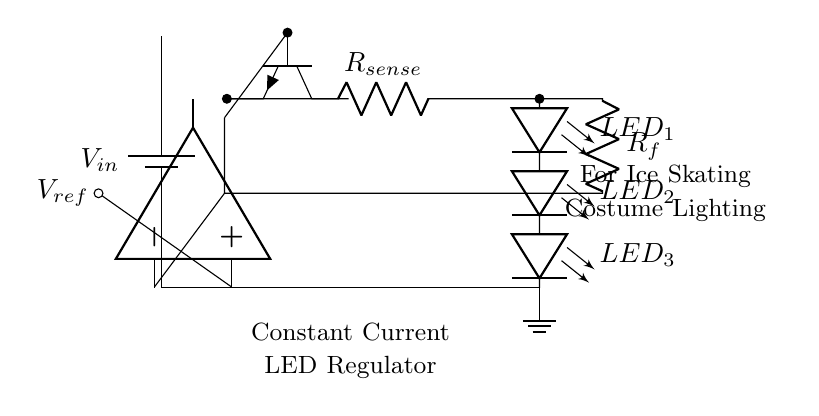What is the type of voltage source in this circuit? The circuit uses a battery, which is shown as the component labeled "Vin." This indicates that it is a direct current source providing a constant voltage.
Answer: battery What is the function of R_sense in the circuit? R_sense is used for current sensing. It measures the current flowing through the LED string, allowing the regulation circuit to adjust the current accordingly to achieve a constant current through the LEDs.
Answer: current sensing How many LEDs are connected in series in this circuit? There are three LEDs identified in the circuit diagram labeled as "LED_1," "LED_2," and "LED_3." Each is connected in series, which means they share the same current and the total voltage across them is the sum of individual voltages.
Answer: three What component controls the output current in this circuit? The npn transistor is responsible for controlling the output current. It adjusts its conductivity based on the feedback from the current sense resistor, maintaining a constant output current to the LEDs.
Answer: npn transistor What is the role of the feedback resistor R_f? R_f is part of the feedback loop that connects the current sense measurement back to the base of the npn transistor. It helps to stabilize and regulate the current supplied to the LEDs by influencing the base current and thus the collector current of the transistor.
Answer: stabilization of current regulation What is indicated by the label V_ref in this circuit? V_ref represents the reference voltage that is compared against the voltage across R_sense. This comparison is used in the feedback loop to control the transistor and maintain the desired output current to the LEDs.
Answer: reference voltage 